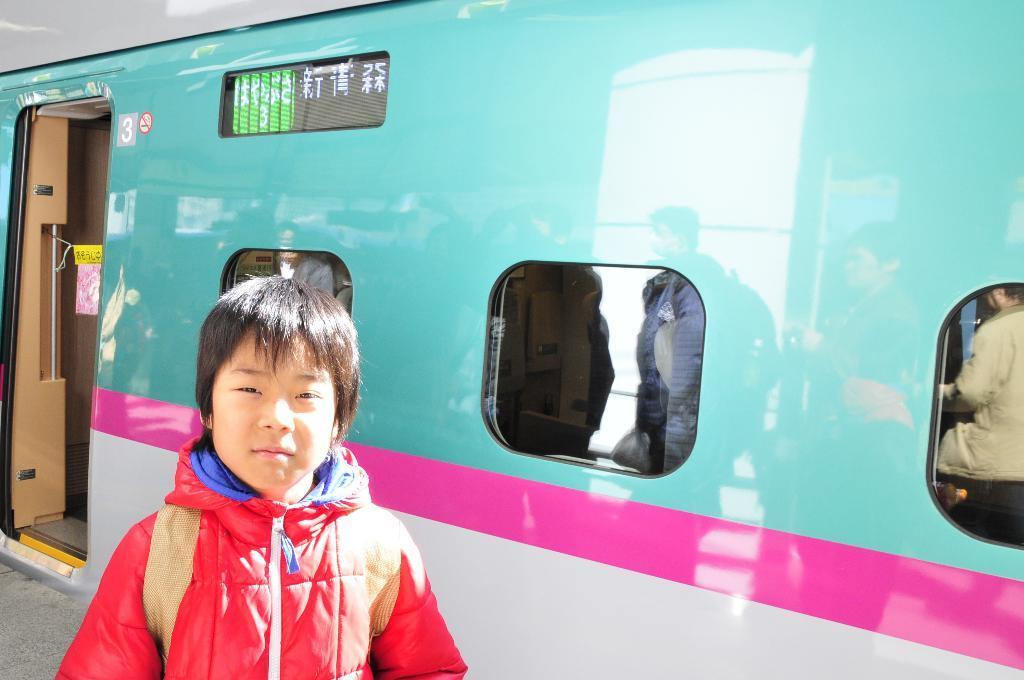Can you describe this image briefly? In this image I can see a child wearing red and blue colored jacket is standing and behind him I can see a train which is blue, pink and white in color. I can see the door and few windows of the train through which I can see few persons. 